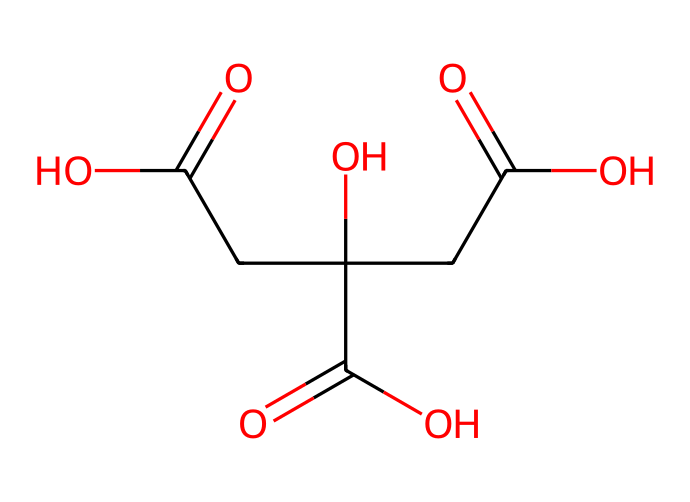What is the molecular formula of citric acid? To find the molecular formula, we identify the elements and their counts from the SMILES representation. The chemical structure shows carbon (C), hydrogen (H), and oxygen (O) atoms. Counting them gives us C6, H8, and O7.
Answer: C6H8O7 How many carboxyl groups are present in citric acid? By analyzing the chemical structure, we can see that there are three carboxyl (–COOH) groups present. Each carboxyl group corresponds to a –C(=O)O segment visible in the SMILES.
Answer: 3 What type of functional groups are found in citric acid? Looking at the structure, we can identify the functional groups: carboxylic acids (–COOH) and hydroxyl (–OH) groups, as seen from the presence of carbonyls and alcohols in the SMILES.
Answer: carboxylic acids and hydroxyl groups What is the pH-regulating property of citric acid linked to? Citric acid’s pH-regulating property is linked to its carboxyl groups, which can donate protons (H+) in solution, thus affecting the acidity; this ability is seen in its structure.
Answer: carboxyl groups How many chiral centers are in citric acid? By examining the structure in the SMILES representation, we can identify chiral centers, which are carbon atoms bonded to four different substituents. There is one chiral carbon in citric acid located at the center of the molecule.
Answer: 1 What type of food preservation method does citric acid primarily use? Citric acid primarily acts as a natural preservative by lowering pH, which inhibits microbial growth in food. This is evident because the multiple carboxyl groups contribute to acidity when dissolved in water.
Answer: lowering pH 